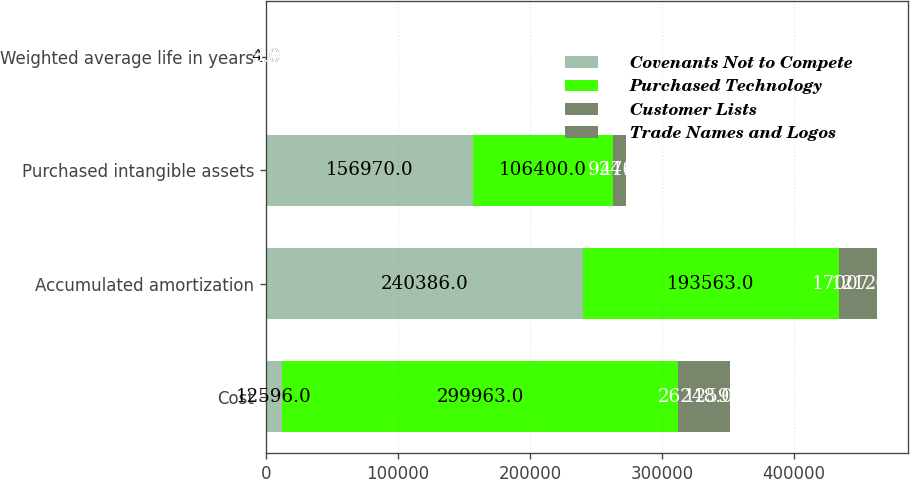Convert chart. <chart><loc_0><loc_0><loc_500><loc_500><stacked_bar_chart><ecel><fcel>Cost<fcel>Accumulated amortization<fcel>Purchased intangible assets<fcel>Weighted average life in years<nl><fcel>Covenants Not to Compete<fcel>12596<fcel>240386<fcel>156970<fcel>5<nl><fcel>Purchased Technology<fcel>299963<fcel>193563<fcel>106400<fcel>4<nl><fcel>Customer Lists<fcel>26248<fcel>17007<fcel>9241<fcel>5<nl><fcel>Trade Names and Logos<fcel>12596<fcel>12120<fcel>476<fcel>3<nl></chart> 